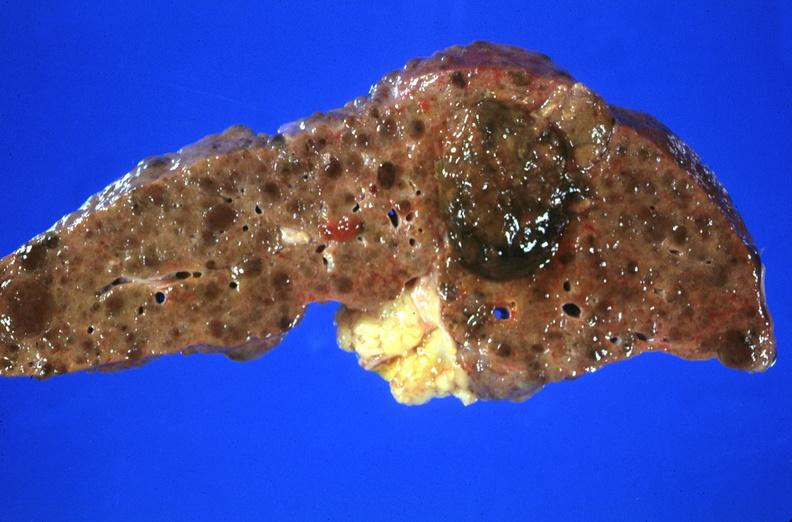does serous cyst show hepatitis b virus, hepatocellular carcinoma?
Answer the question using a single word or phrase. No 